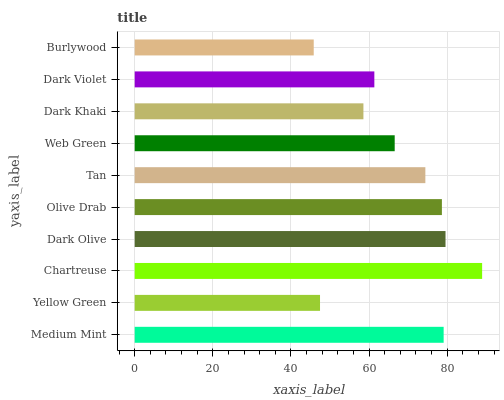Is Burlywood the minimum?
Answer yes or no. Yes. Is Chartreuse the maximum?
Answer yes or no. Yes. Is Yellow Green the minimum?
Answer yes or no. No. Is Yellow Green the maximum?
Answer yes or no. No. Is Medium Mint greater than Yellow Green?
Answer yes or no. Yes. Is Yellow Green less than Medium Mint?
Answer yes or no. Yes. Is Yellow Green greater than Medium Mint?
Answer yes or no. No. Is Medium Mint less than Yellow Green?
Answer yes or no. No. Is Tan the high median?
Answer yes or no. Yes. Is Web Green the low median?
Answer yes or no. Yes. Is Dark Khaki the high median?
Answer yes or no. No. Is Yellow Green the low median?
Answer yes or no. No. 